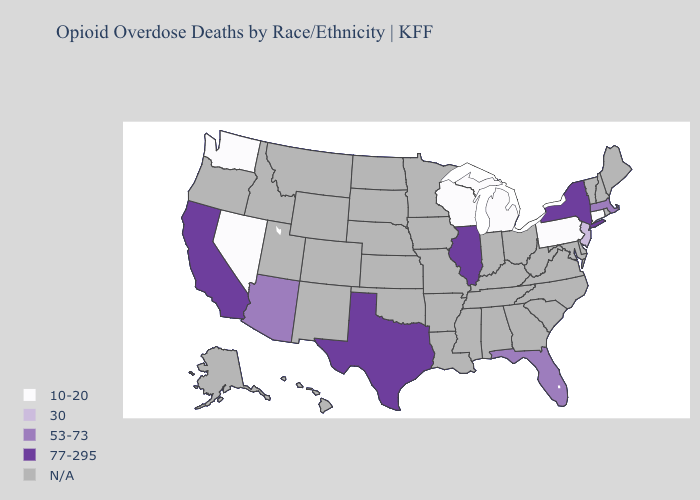What is the value of Wyoming?
Write a very short answer. N/A. What is the highest value in the Northeast ?
Concise answer only. 77-295. Does Arizona have the highest value in the USA?
Be succinct. No. Name the states that have a value in the range 30?
Keep it brief. New Jersey. What is the value of Missouri?
Answer briefly. N/A. Which states hav the highest value in the MidWest?
Concise answer only. Illinois. Name the states that have a value in the range 77-295?
Give a very brief answer. California, Illinois, New York, Texas. Is the legend a continuous bar?
Write a very short answer. No. What is the highest value in states that border Illinois?
Keep it brief. 10-20. Does Washington have the highest value in the USA?
Write a very short answer. No. Name the states that have a value in the range N/A?
Quick response, please. Alabama, Alaska, Arkansas, Colorado, Delaware, Georgia, Hawaii, Idaho, Indiana, Iowa, Kansas, Kentucky, Louisiana, Maine, Maryland, Minnesota, Mississippi, Missouri, Montana, Nebraska, New Hampshire, New Mexico, North Carolina, North Dakota, Ohio, Oklahoma, Oregon, Rhode Island, South Carolina, South Dakota, Tennessee, Utah, Vermont, Virginia, West Virginia, Wyoming. Does Massachusetts have the lowest value in the Northeast?
Write a very short answer. No. What is the value of Arizona?
Be succinct. 53-73. What is the value of New Hampshire?
Concise answer only. N/A. 